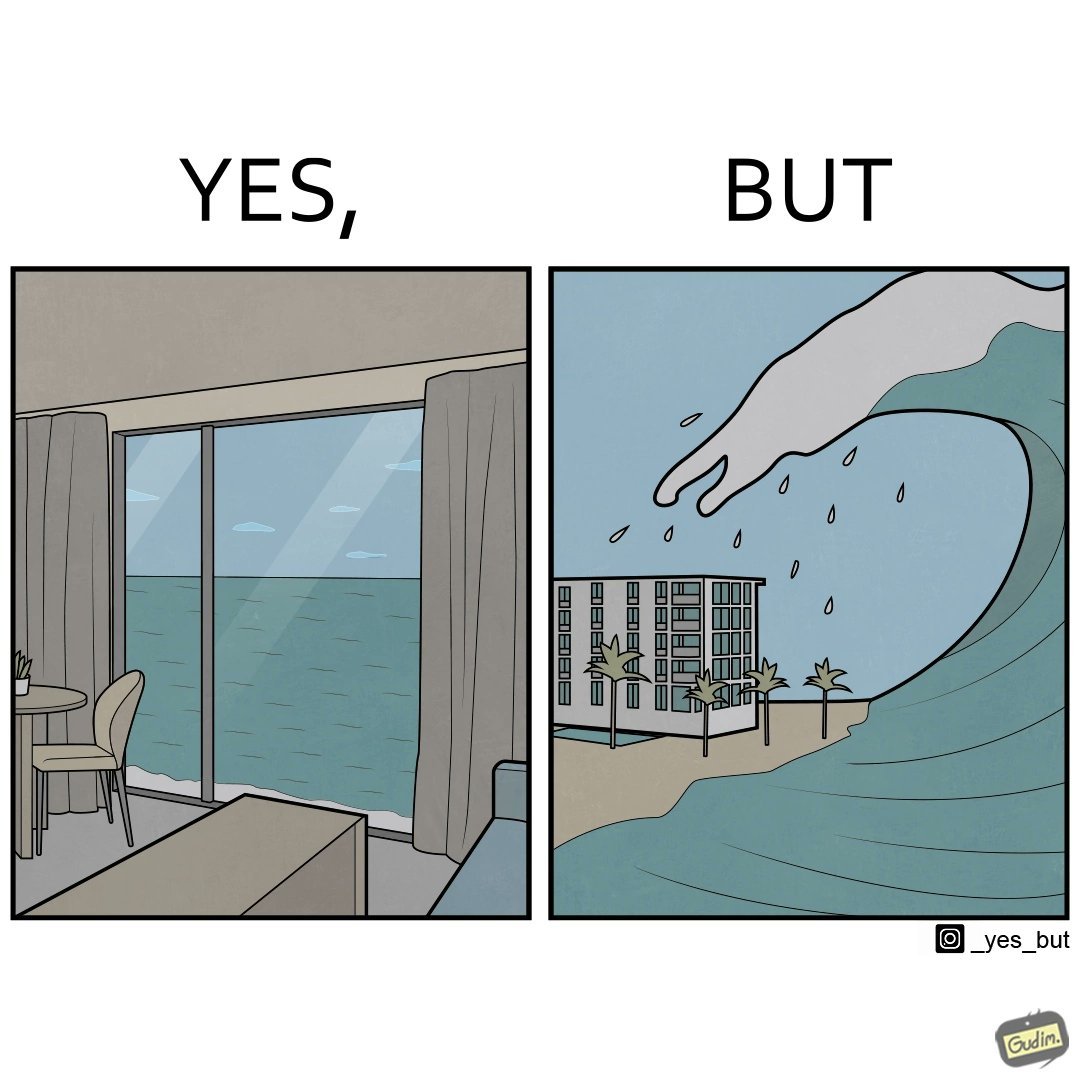What does this image depict? The same sea which gives us a relaxation on a normal day can pose a danger to us sometimes like during a tsunami 